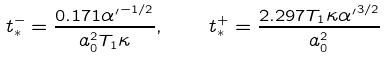<formula> <loc_0><loc_0><loc_500><loc_500>t _ { * } ^ { - } = \frac { 0 . 1 7 1 { \alpha ^ { \prime } } ^ { - 1 / 2 } } { a _ { 0 } ^ { 2 } T _ { 1 } \kappa } , \quad t _ { * } ^ { + } = \frac { 2 . 2 9 7 T _ { 1 } \kappa { \alpha ^ { \prime } } ^ { 3 / 2 } } { a _ { 0 } ^ { 2 } }</formula> 